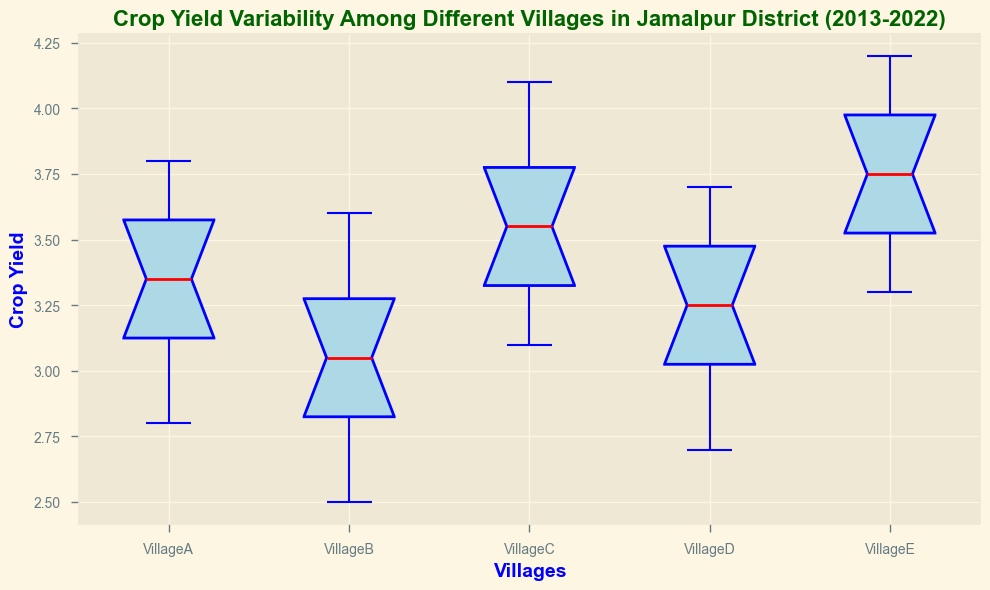What is the median crop yield in Village A over the last decade? To find the median, we need to locate the middle value of the crop yields in Village A when listed in ascending order: [2.8, 3.0, 3.1, 3.2, 3.3, 3.4, 3.5, 3.6, 3.7, 3.8]. The median is (3.3 + 3.4) / 2 = 3.35
Answer: 3.35 Which village has the highest median crop yield? By comparing the position of the median line on each box plot, Village E has the highest median crop yield, as its median line is at 4.0.
Answer: Village E What is the range of crop yields for Village B? The range is calculated as the difference between the maximum and minimum crop yields. From the box plot, the maximum is 3.6, and the minimum is 2.5. Therefore, the range is 3.6 - 2.5 = 1.1
Answer: 1.1 Which village shows the least variability in crop yields over the decade? The variability is indicated by the interquartile range (IQR). Village B has the smallest IQR, which indicates the least variability among the villages.
Answer: Village B How many villages have a median crop yield above 3.5? By examining the box plots, the villages with a median line above 3.5 are Village C and Village E.
Answer: 2 Which village has the largest interquartile range (IQR) for crop yields? The IQR is represented by the length of the box in the box plot. Comparing the box lengths, Village C has the largest IQR.
Answer: Village C What is the difference in median crop yields between Village D and Village E? The median for Village D is at 3.3, and the median for Village E is at 4.0. The difference is 4.0 - 3.3 = 0.7
Answer: 0.7 Which village has the lowest minimum crop yield over the last decade? By examining the lower whiskers of the box plots, Village B has the lowest minimum crop yield at 2.5.
Answer: Village B Are there any outliers in the crop yields for any of the villages? Outliers are typically represented by individual points outside the whiskers of the box plot. In this data, there are no outliers visible in any of the villages.
Answer: No 